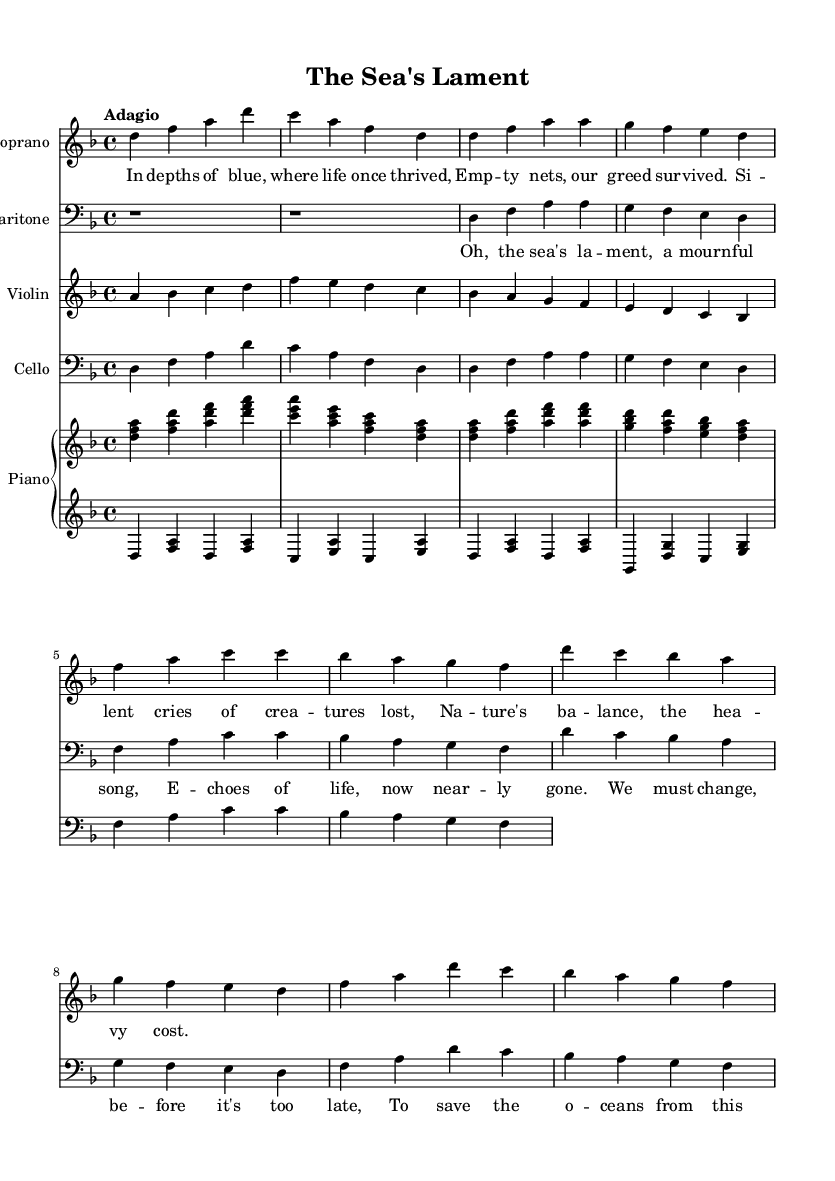What is the key signature of this music? The key signature is indicated at the beginning of the score and shows two flats, which represents D minor.
Answer: D minor What is the time signature of this piece? The time signature is shown at the beginning of the score, indicating four beats per measure (4/4).
Answer: 4/4 What is the tempo marking for this opera? The tempo marking appears at the beginning and is marked "Adagio," which indicates a slow tempo.
Answer: Adagio How many voice parts are included in this opera? The score shows three distinct voice parts: soprano, baritone, and the chorus, indicating a total of three.
Answer: Three What is the theme of the chorus lyrics? By analyzing the lyrics, the chorus expresses the sorrowful impact of human actions on the oceans' life, calling for change to prevent further loss.
Answer: Environmental sorrow How does the soprano part begin? The soprano part starts with the note D in the treble clef, as shown in the score.
Answer: D What do the lyrics in verse one convey? The lyrics express themes of loss and the consequences of greed in the context of marine ecosystems, showcasing the emotional weight of the subject matter.
Answer: Loss and consequence 